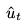<formula> <loc_0><loc_0><loc_500><loc_500>\hat { u } _ { t }</formula> 